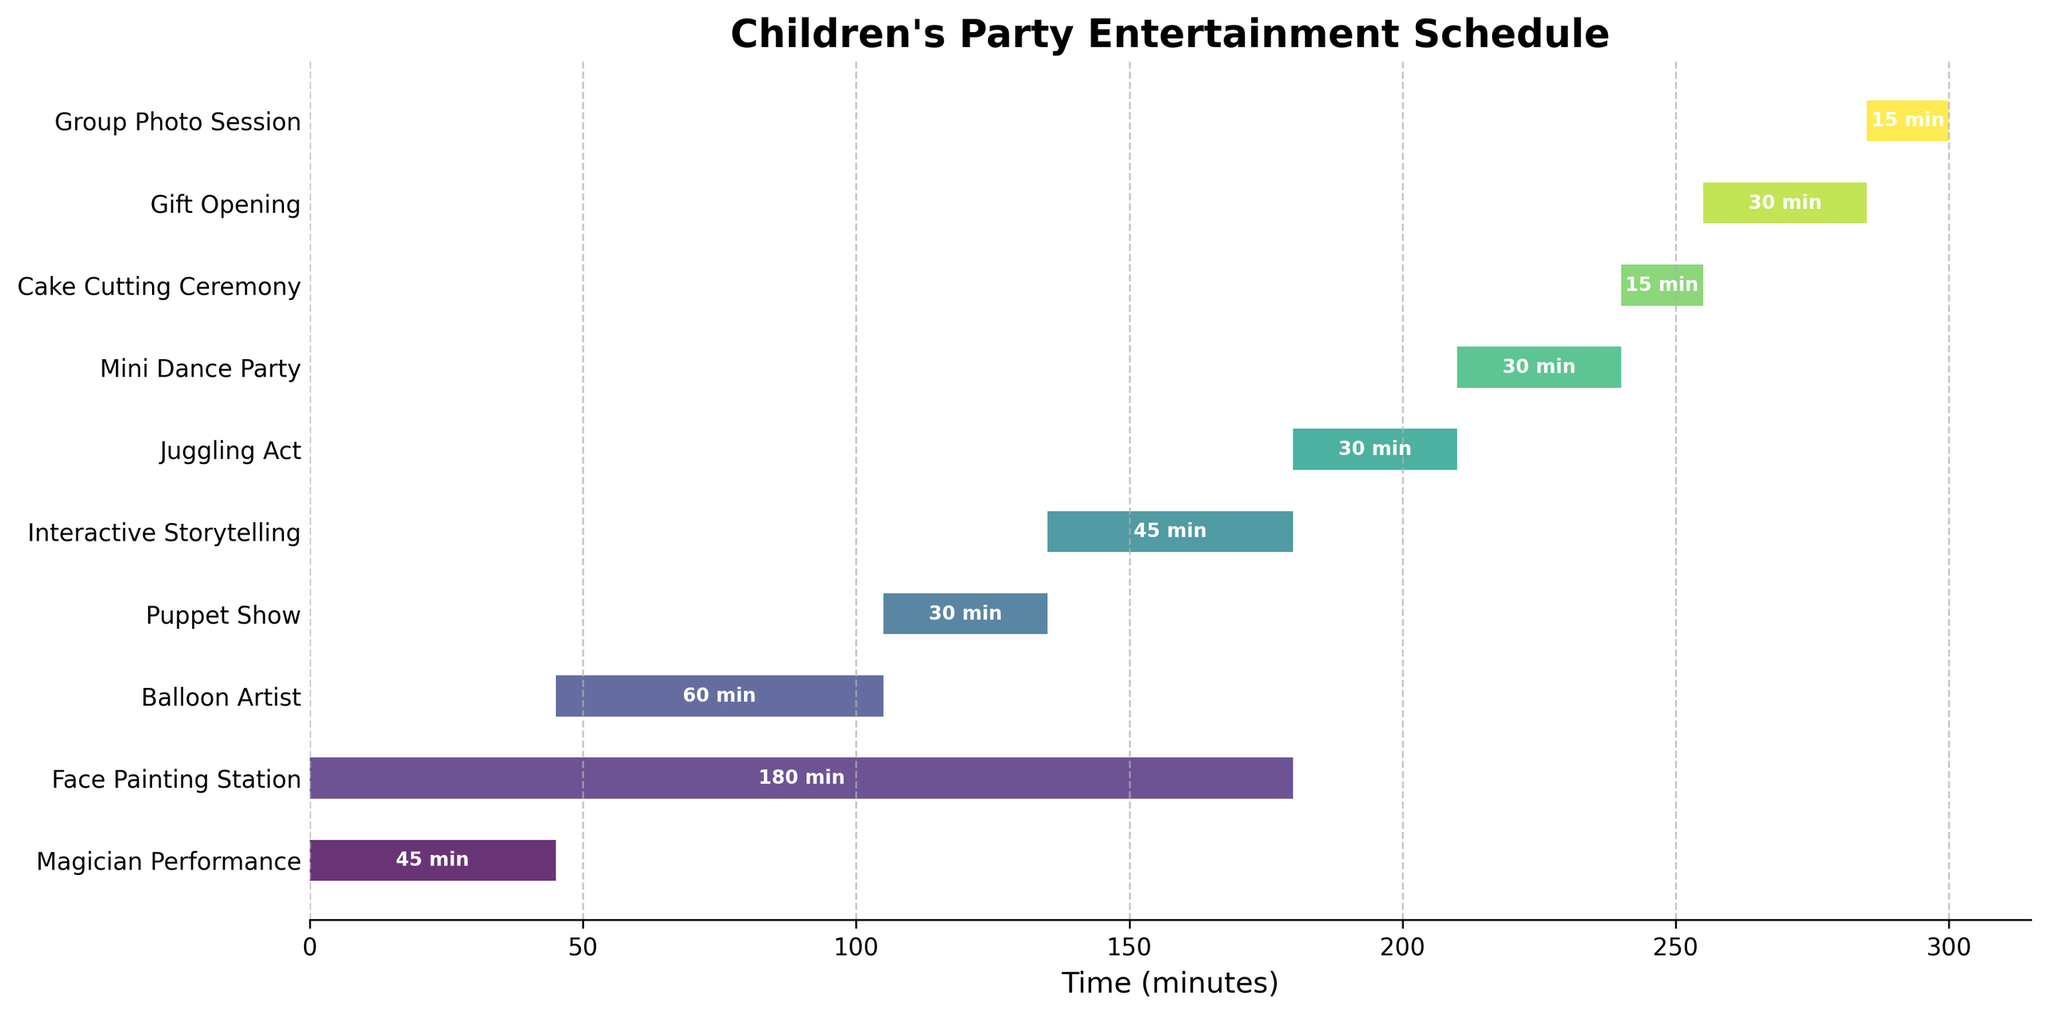What is the total duration of the "Face Painting Station"? Look at the duration column in the figure, which shows that the "Face Painting Station" lasts for 180 minutes.
Answer: 180 minutes How long is the "Magician Performance" compared to the "Puppet Show"? The "Magician Performance" lasts for 45 minutes, and the "Puppet Show" lasts for 30 minutes. Subtract the duration of the "Puppet Show" from the "Magician Performance" to get the difference: 45 - 30.
Answer: 15 minutes longer Which act starts right after the "Magician Performance"? The "Magician Performance" ends at 45 minutes (0 + 45), and looking at the next act's start time, the "Balloon Artist" starts at 45 minutes.
Answer: Balloon Artist What is the total duration of all the acts combined? Add the durations of all acts listed: 45 (Magician Performance) + 180 (Face Painting Station) + 60 (Balloon Artist) + 30 (Puppet Show) + 45 (Interactive Storytelling) + 30 (Juggling Act) + 30 (Mini Dance Party) + 15 (Cake Cutting Ceremony) + 30 (Gift Opening) + 15 (Group Photo Session) = 480 minutes.
Answer: 480 minutes Are there any breaks between the acts? Check if there are any gaps between the end time of one act and the start time of the subsequent act. For example, the "Balloon Artist" ends at 105 minutes (45 + 60), and the "Puppet Show" starts at 105 minutes. This pattern continues for subsequent acts, indicating no breaks.
Answer: No Which act takes place simultaneously with another act? Look at the start times and durations of all acts. Both "Magician Performance" and "Face Painting Station" start at 0 minutes and overlap for 45 minutes.
Answer: Magician Performance and Face Painting Station When does the "Cake Cutting Ceremony" end? The "Cake Cutting Ceremony" starts at 240 minutes and lasts for 15 minutes. Adding the duration to the start time: 240 + 15 = 255 minutes.
Answer: 255 minutes How many acts are longer than 30 minutes? Count the acts with a duration greater than 30 minutes: "Magician Performance" (45), "Face Painting Station" (180), "Balloon Artist" (60), and "Interactive Storytelling" (45). There are four acts.
Answer: 4 acts What is the shortest act in the schedule? Compare the durations of all the acts and find the shortest one: both "Cake Cutting Ceremony" and "Group Photo Session" last for 15 minutes.
Answer: Cake Cutting Ceremony and Group Photo Session Which two acts are back-to-back without any overlap? Search for two acts where one ends and the other begins immediately. "Interactive Storytelling" ends at 180 minutes (135 + 45) and the "Juggling Act" starts at 180 minutes.
Answer: Interactive Storytelling and Juggling Act 